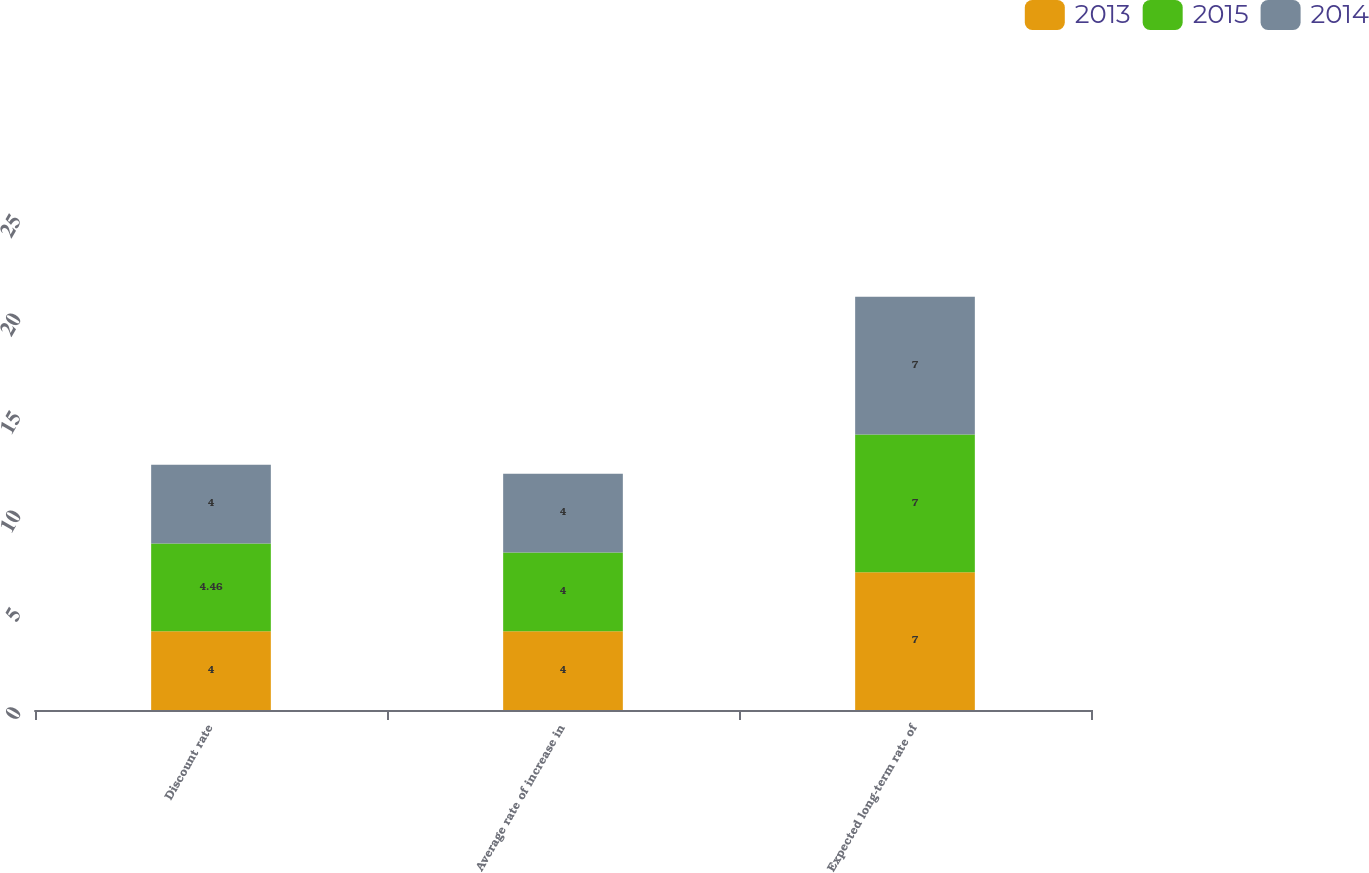Convert chart to OTSL. <chart><loc_0><loc_0><loc_500><loc_500><stacked_bar_chart><ecel><fcel>Discount rate<fcel>Average rate of increase in<fcel>Expected long-term rate of<nl><fcel>2013<fcel>4<fcel>4<fcel>7<nl><fcel>2015<fcel>4.46<fcel>4<fcel>7<nl><fcel>2014<fcel>4<fcel>4<fcel>7<nl></chart> 